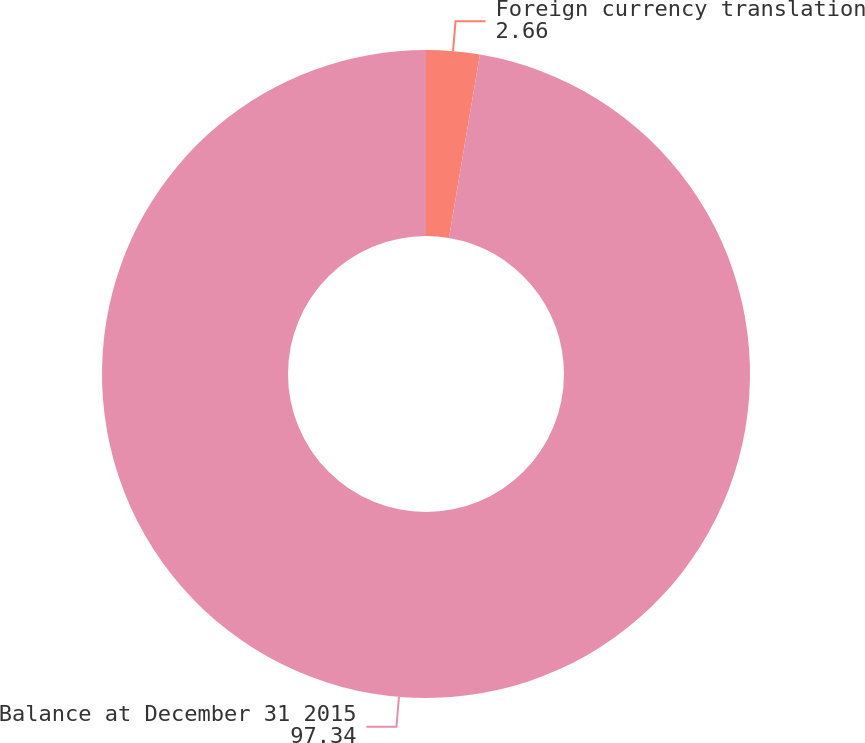Convert chart to OTSL. <chart><loc_0><loc_0><loc_500><loc_500><pie_chart><fcel>Foreign currency translation<fcel>Balance at December 31 2015<nl><fcel>2.66%<fcel>97.34%<nl></chart> 